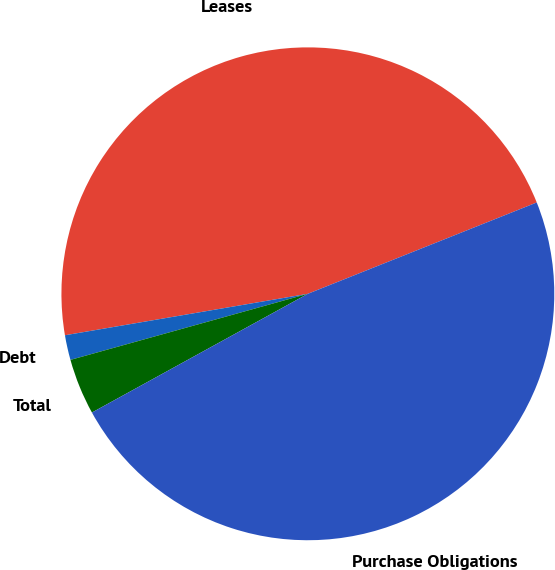<chart> <loc_0><loc_0><loc_500><loc_500><pie_chart><fcel>Leases<fcel>Debt<fcel>Total<fcel>Purchase Obligations<nl><fcel>46.65%<fcel>1.63%<fcel>3.68%<fcel>48.04%<nl></chart> 